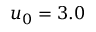<formula> <loc_0><loc_0><loc_500><loc_500>u _ { 0 } = 3 . 0</formula> 